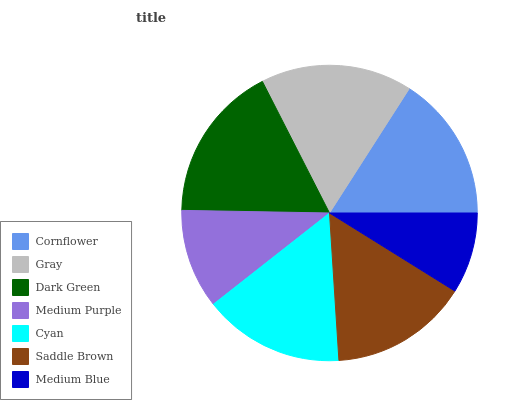Is Medium Blue the minimum?
Answer yes or no. Yes. Is Dark Green the maximum?
Answer yes or no. Yes. Is Gray the minimum?
Answer yes or no. No. Is Gray the maximum?
Answer yes or no. No. Is Gray greater than Cornflower?
Answer yes or no. Yes. Is Cornflower less than Gray?
Answer yes or no. Yes. Is Cornflower greater than Gray?
Answer yes or no. No. Is Gray less than Cornflower?
Answer yes or no. No. Is Cyan the high median?
Answer yes or no. Yes. Is Cyan the low median?
Answer yes or no. Yes. Is Gray the high median?
Answer yes or no. No. Is Medium Blue the low median?
Answer yes or no. No. 